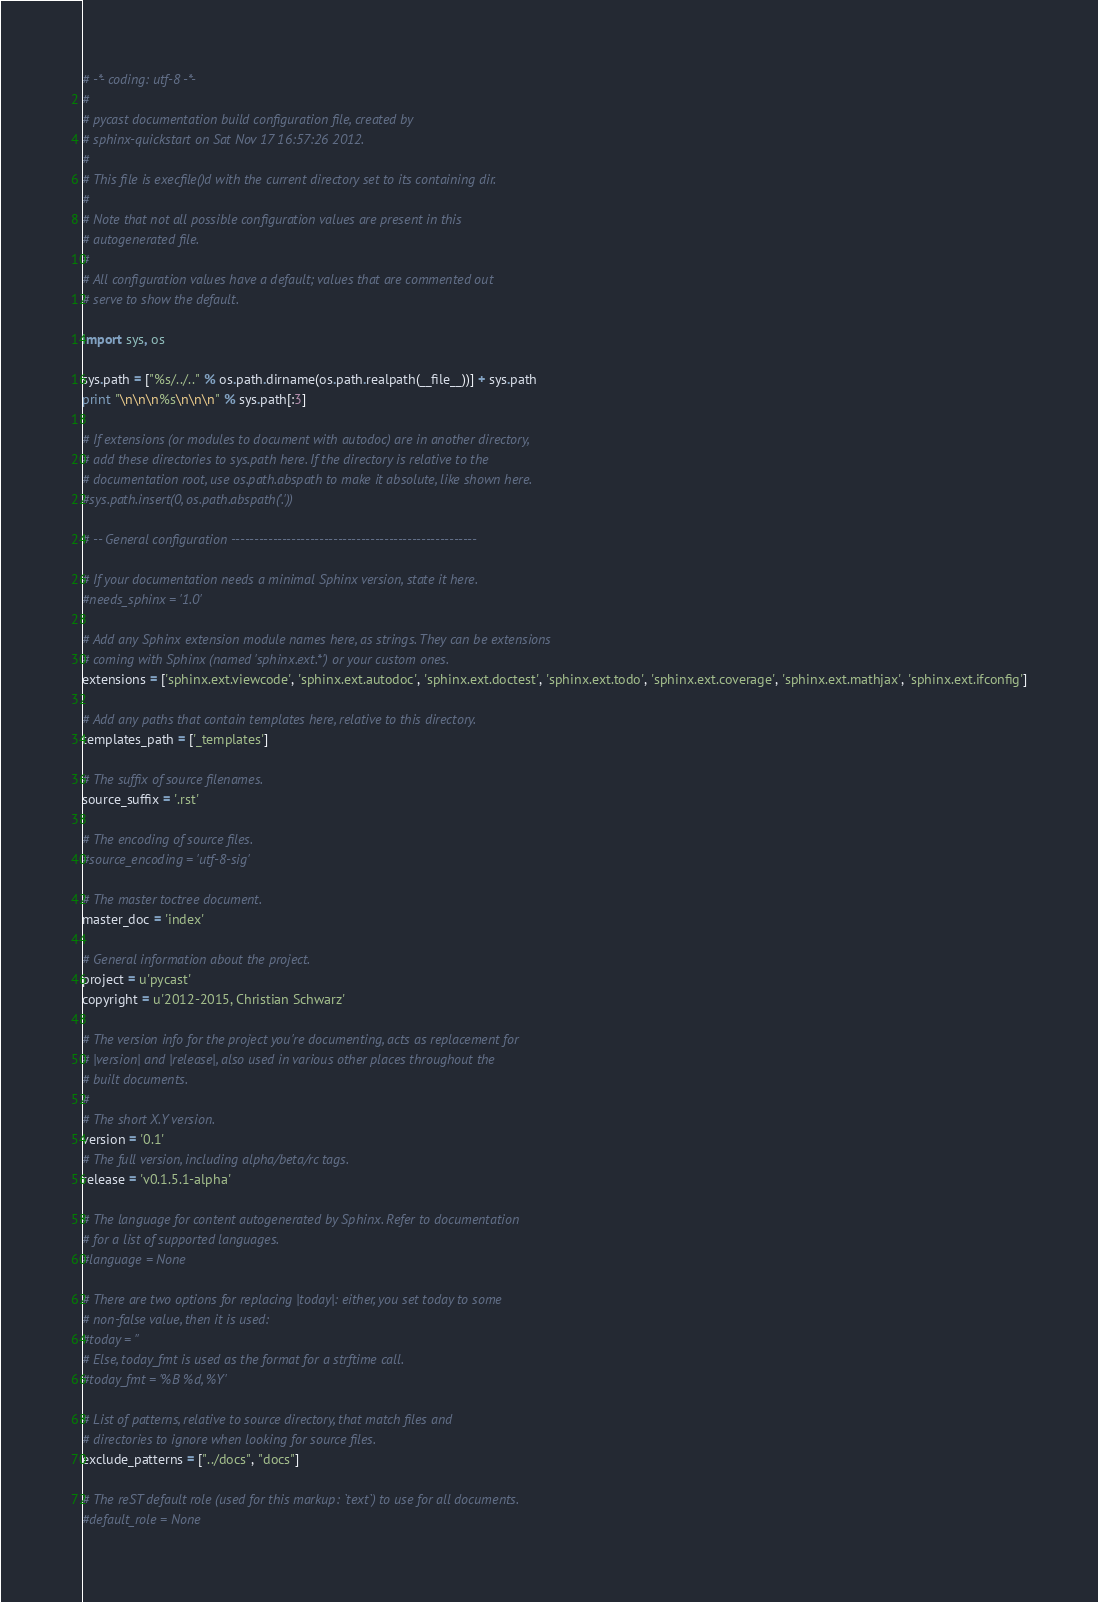<code> <loc_0><loc_0><loc_500><loc_500><_Python_># -*- coding: utf-8 -*-
#
# pycast documentation build configuration file, created by
# sphinx-quickstart on Sat Nov 17 16:57:26 2012.
#
# This file is execfile()d with the current directory set to its containing dir.
#
# Note that not all possible configuration values are present in this
# autogenerated file.
#
# All configuration values have a default; values that are commented out
# serve to show the default.

import sys, os

sys.path = ["%s/../.." % os.path.dirname(os.path.realpath(__file__))] + sys.path
print "\n\n\n%s\n\n\n" % sys.path[:3]

# If extensions (or modules to document with autodoc) are in another directory,
# add these directories to sys.path here. If the directory is relative to the
# documentation root, use os.path.abspath to make it absolute, like shown here.
#sys.path.insert(0, os.path.abspath('.'))

# -- General configuration -----------------------------------------------------

# If your documentation needs a minimal Sphinx version, state it here.
#needs_sphinx = '1.0'

# Add any Sphinx extension module names here, as strings. They can be extensions
# coming with Sphinx (named 'sphinx.ext.*') or your custom ones.
extensions = ['sphinx.ext.viewcode', 'sphinx.ext.autodoc', 'sphinx.ext.doctest', 'sphinx.ext.todo', 'sphinx.ext.coverage', 'sphinx.ext.mathjax', 'sphinx.ext.ifconfig']

# Add any paths that contain templates here, relative to this directory.
templates_path = ['_templates']

# The suffix of source filenames.
source_suffix = '.rst'

# The encoding of source files.
#source_encoding = 'utf-8-sig'

# The master toctree document.
master_doc = 'index'

# General information about the project.
project = u'pycast'
copyright = u'2012-2015, Christian Schwarz'

# The version info for the project you're documenting, acts as replacement for
# |version| and |release|, also used in various other places throughout the
# built documents.
#
# The short X.Y version.
version = '0.1'
# The full version, including alpha/beta/rc tags.
release = 'v0.1.5.1-alpha'

# The language for content autogenerated by Sphinx. Refer to documentation
# for a list of supported languages.
#language = None

# There are two options for replacing |today|: either, you set today to some
# non-false value, then it is used:
#today = ''
# Else, today_fmt is used as the format for a strftime call.
#today_fmt = '%B %d, %Y'

# List of patterns, relative to source directory, that match files and
# directories to ignore when looking for source files.
exclude_patterns = ["../docs", "docs"]

# The reST default role (used for this markup: `text`) to use for all documents.
#default_role = None
</code> 